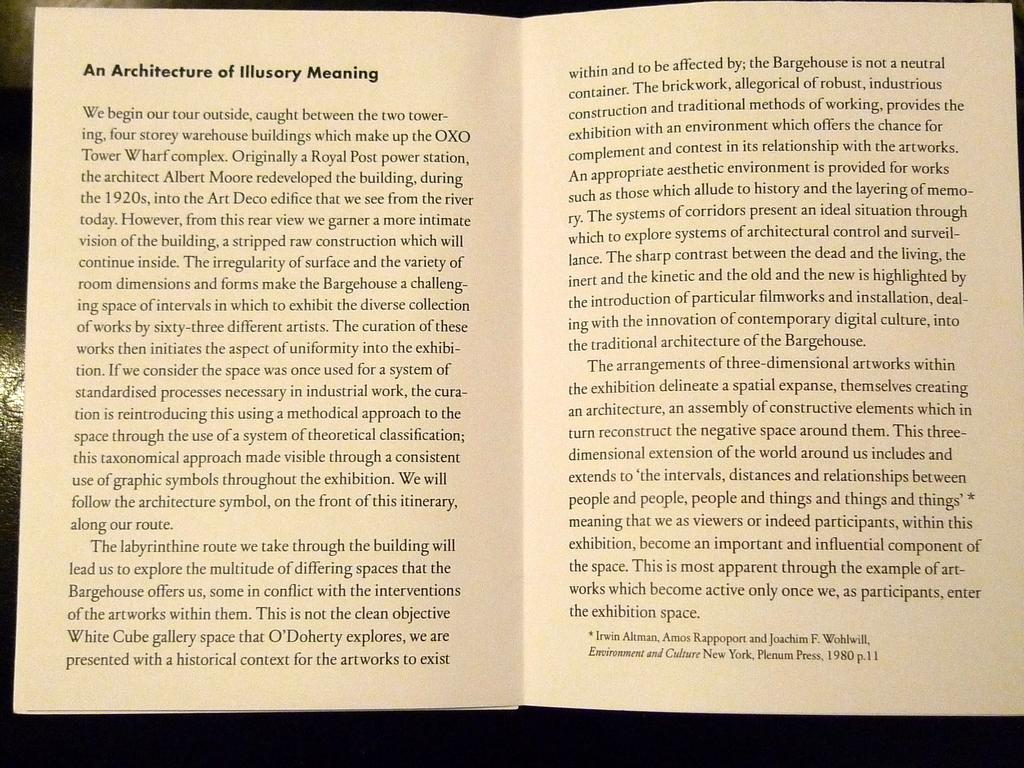<image>
Summarize the visual content of the image. "An Architecture of Illusory Meaning" is open to a center page. 